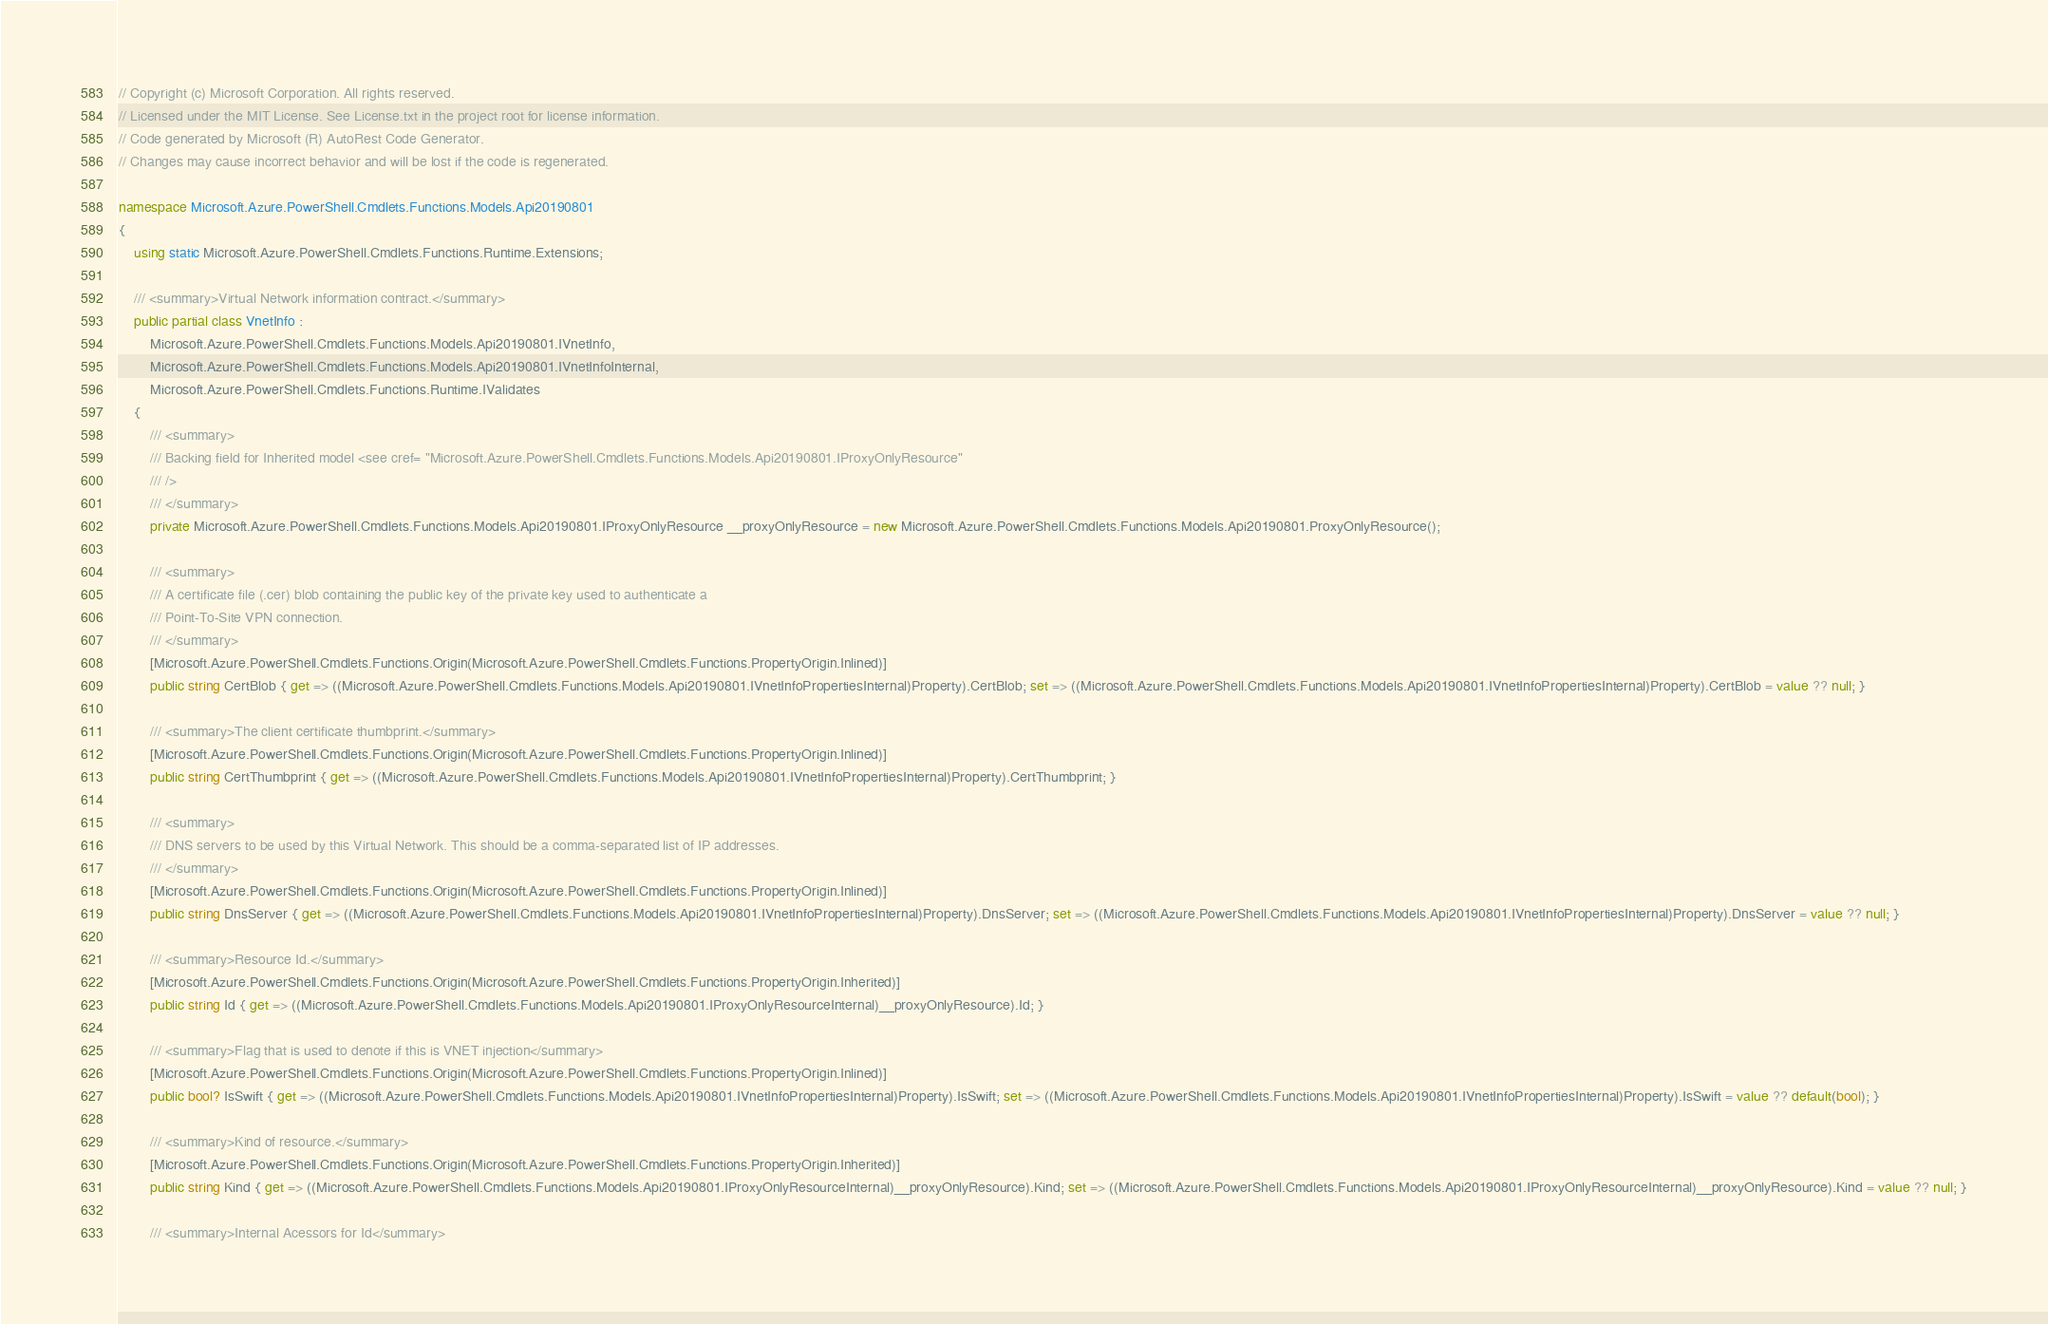Convert code to text. <code><loc_0><loc_0><loc_500><loc_500><_C#_>// Copyright (c) Microsoft Corporation. All rights reserved.
// Licensed under the MIT License. See License.txt in the project root for license information.
// Code generated by Microsoft (R) AutoRest Code Generator.
// Changes may cause incorrect behavior and will be lost if the code is regenerated.

namespace Microsoft.Azure.PowerShell.Cmdlets.Functions.Models.Api20190801
{
    using static Microsoft.Azure.PowerShell.Cmdlets.Functions.Runtime.Extensions;

    /// <summary>Virtual Network information contract.</summary>
    public partial class VnetInfo :
        Microsoft.Azure.PowerShell.Cmdlets.Functions.Models.Api20190801.IVnetInfo,
        Microsoft.Azure.PowerShell.Cmdlets.Functions.Models.Api20190801.IVnetInfoInternal,
        Microsoft.Azure.PowerShell.Cmdlets.Functions.Runtime.IValidates
    {
        /// <summary>
        /// Backing field for Inherited model <see cref= "Microsoft.Azure.PowerShell.Cmdlets.Functions.Models.Api20190801.IProxyOnlyResource"
        /// />
        /// </summary>
        private Microsoft.Azure.PowerShell.Cmdlets.Functions.Models.Api20190801.IProxyOnlyResource __proxyOnlyResource = new Microsoft.Azure.PowerShell.Cmdlets.Functions.Models.Api20190801.ProxyOnlyResource();

        /// <summary>
        /// A certificate file (.cer) blob containing the public key of the private key used to authenticate a
        /// Point-To-Site VPN connection.
        /// </summary>
        [Microsoft.Azure.PowerShell.Cmdlets.Functions.Origin(Microsoft.Azure.PowerShell.Cmdlets.Functions.PropertyOrigin.Inlined)]
        public string CertBlob { get => ((Microsoft.Azure.PowerShell.Cmdlets.Functions.Models.Api20190801.IVnetInfoPropertiesInternal)Property).CertBlob; set => ((Microsoft.Azure.PowerShell.Cmdlets.Functions.Models.Api20190801.IVnetInfoPropertiesInternal)Property).CertBlob = value ?? null; }

        /// <summary>The client certificate thumbprint.</summary>
        [Microsoft.Azure.PowerShell.Cmdlets.Functions.Origin(Microsoft.Azure.PowerShell.Cmdlets.Functions.PropertyOrigin.Inlined)]
        public string CertThumbprint { get => ((Microsoft.Azure.PowerShell.Cmdlets.Functions.Models.Api20190801.IVnetInfoPropertiesInternal)Property).CertThumbprint; }

        /// <summary>
        /// DNS servers to be used by this Virtual Network. This should be a comma-separated list of IP addresses.
        /// </summary>
        [Microsoft.Azure.PowerShell.Cmdlets.Functions.Origin(Microsoft.Azure.PowerShell.Cmdlets.Functions.PropertyOrigin.Inlined)]
        public string DnsServer { get => ((Microsoft.Azure.PowerShell.Cmdlets.Functions.Models.Api20190801.IVnetInfoPropertiesInternal)Property).DnsServer; set => ((Microsoft.Azure.PowerShell.Cmdlets.Functions.Models.Api20190801.IVnetInfoPropertiesInternal)Property).DnsServer = value ?? null; }

        /// <summary>Resource Id.</summary>
        [Microsoft.Azure.PowerShell.Cmdlets.Functions.Origin(Microsoft.Azure.PowerShell.Cmdlets.Functions.PropertyOrigin.Inherited)]
        public string Id { get => ((Microsoft.Azure.PowerShell.Cmdlets.Functions.Models.Api20190801.IProxyOnlyResourceInternal)__proxyOnlyResource).Id; }

        /// <summary>Flag that is used to denote if this is VNET injection</summary>
        [Microsoft.Azure.PowerShell.Cmdlets.Functions.Origin(Microsoft.Azure.PowerShell.Cmdlets.Functions.PropertyOrigin.Inlined)]
        public bool? IsSwift { get => ((Microsoft.Azure.PowerShell.Cmdlets.Functions.Models.Api20190801.IVnetInfoPropertiesInternal)Property).IsSwift; set => ((Microsoft.Azure.PowerShell.Cmdlets.Functions.Models.Api20190801.IVnetInfoPropertiesInternal)Property).IsSwift = value ?? default(bool); }

        /// <summary>Kind of resource.</summary>
        [Microsoft.Azure.PowerShell.Cmdlets.Functions.Origin(Microsoft.Azure.PowerShell.Cmdlets.Functions.PropertyOrigin.Inherited)]
        public string Kind { get => ((Microsoft.Azure.PowerShell.Cmdlets.Functions.Models.Api20190801.IProxyOnlyResourceInternal)__proxyOnlyResource).Kind; set => ((Microsoft.Azure.PowerShell.Cmdlets.Functions.Models.Api20190801.IProxyOnlyResourceInternal)__proxyOnlyResource).Kind = value ?? null; }

        /// <summary>Internal Acessors for Id</summary></code> 